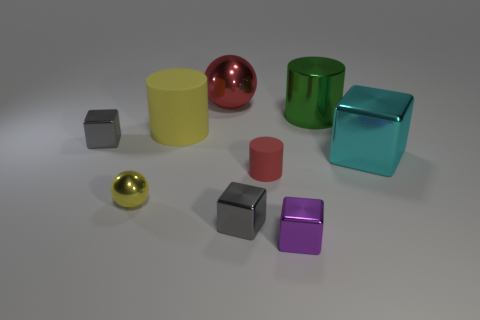Which objects in the picture seem to be the farthest away in the scene? The objects farthest away in the scene are the large red metal sphere and the large green metallic cube. They are positioned towards the back of the image and appear smaller due to the perspective. 